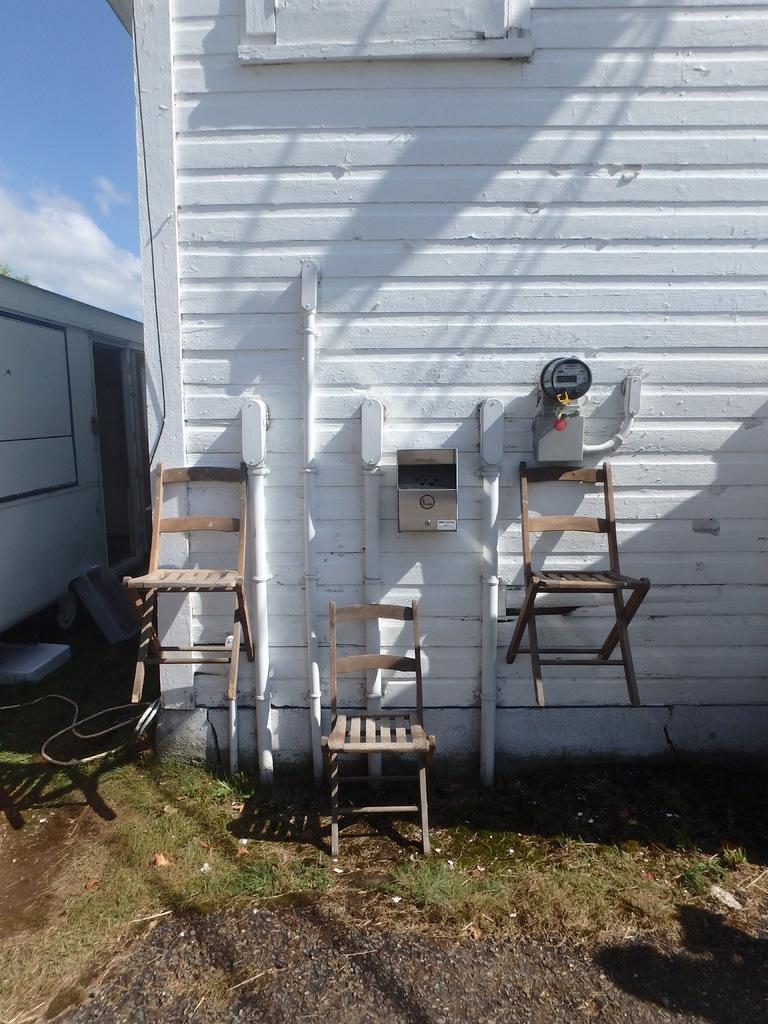Can you describe this image briefly? In the image in the center we can see one vehicle,wall,pipes,meter,box,three wooden chairs,grass etc. In the background we can see sky and clouds. 